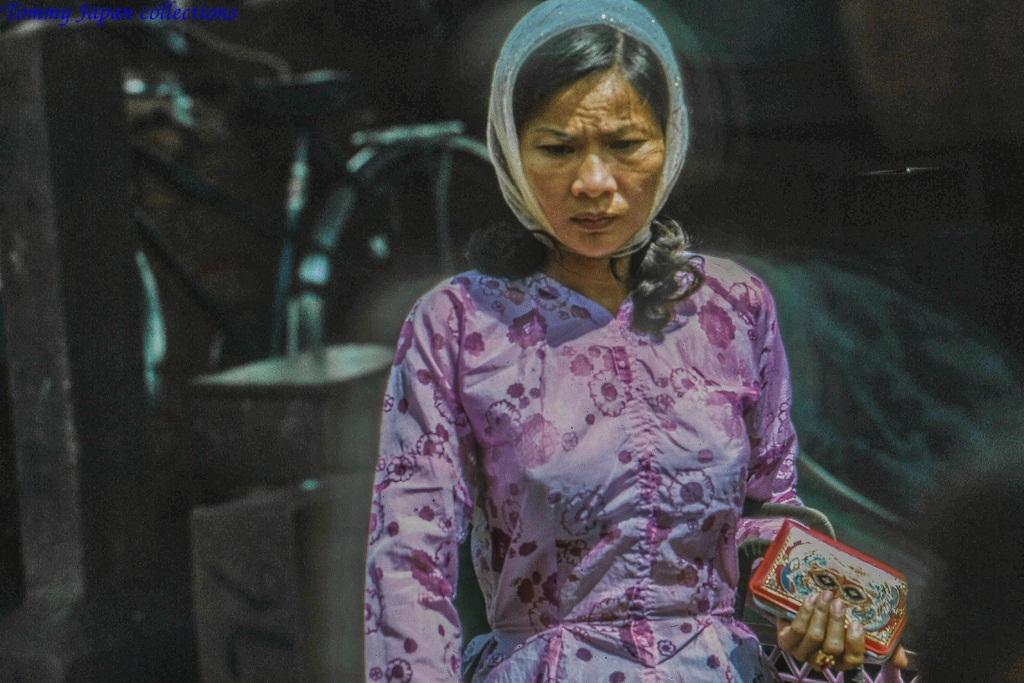In one or two sentences, can you explain what this image depicts? In this picture we can see a woman holding a purse in her hand. There is a bicycle and other objects visible in the background. It seems like the background is blurry. There is some text visible in the top left. 